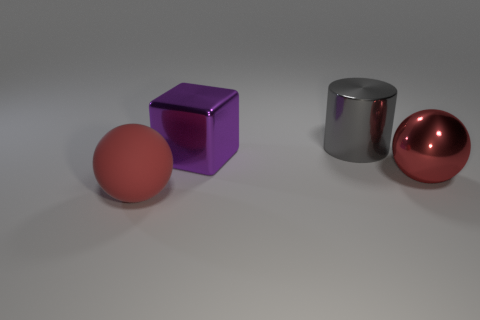What could the color choices tell us about the design intention? The use of primary colors might suggest a desire to highlight the pure geometry of the shapes. The color contrast helps to clearly distinguish each object, potentially serving an educational or demonstrative purpose, like explaining concepts in geometry or design. 